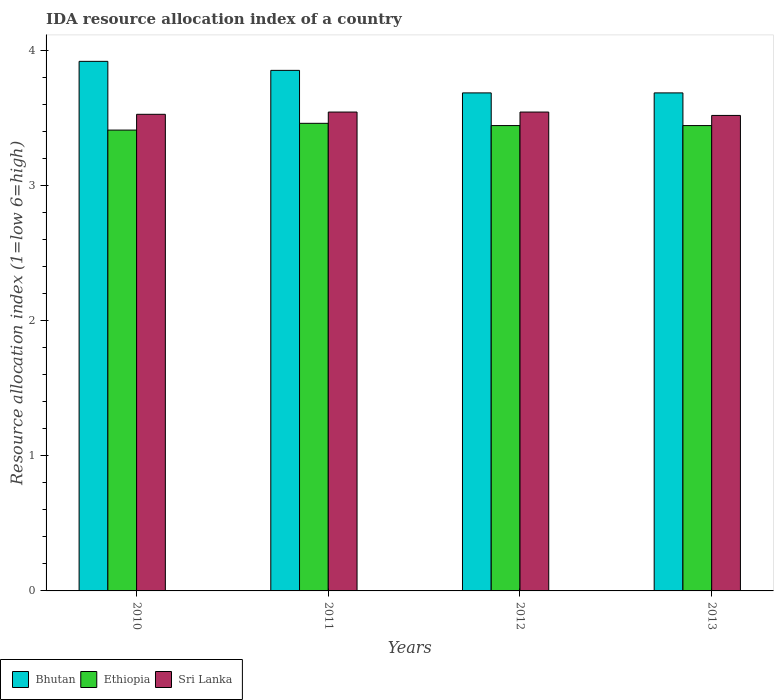How many different coloured bars are there?
Offer a terse response. 3. Are the number of bars on each tick of the X-axis equal?
Ensure brevity in your answer.  Yes. How many bars are there on the 2nd tick from the left?
Your response must be concise. 3. What is the label of the 4th group of bars from the left?
Your answer should be very brief. 2013. In how many cases, is the number of bars for a given year not equal to the number of legend labels?
Your answer should be compact. 0. What is the IDA resource allocation index in Ethiopia in 2011?
Your answer should be very brief. 3.46. Across all years, what is the maximum IDA resource allocation index in Bhutan?
Provide a short and direct response. 3.92. Across all years, what is the minimum IDA resource allocation index in Ethiopia?
Your answer should be compact. 3.41. In which year was the IDA resource allocation index in Sri Lanka maximum?
Keep it short and to the point. 2011. In which year was the IDA resource allocation index in Sri Lanka minimum?
Keep it short and to the point. 2013. What is the total IDA resource allocation index in Bhutan in the graph?
Give a very brief answer. 15.13. What is the difference between the IDA resource allocation index in Bhutan in 2010 and that in 2012?
Give a very brief answer. 0.23. What is the difference between the IDA resource allocation index in Ethiopia in 2010 and the IDA resource allocation index in Bhutan in 2013?
Your answer should be very brief. -0.27. What is the average IDA resource allocation index in Sri Lanka per year?
Offer a very short reply. 3.53. In the year 2011, what is the difference between the IDA resource allocation index in Ethiopia and IDA resource allocation index in Sri Lanka?
Provide a short and direct response. -0.08. In how many years, is the IDA resource allocation index in Ethiopia greater than 2.8?
Provide a succinct answer. 4. What is the ratio of the IDA resource allocation index in Bhutan in 2011 to that in 2012?
Offer a very short reply. 1.05. Is the IDA resource allocation index in Bhutan in 2011 less than that in 2012?
Provide a succinct answer. No. Is the difference between the IDA resource allocation index in Ethiopia in 2011 and 2012 greater than the difference between the IDA resource allocation index in Sri Lanka in 2011 and 2012?
Give a very brief answer. Yes. What is the difference between the highest and the second highest IDA resource allocation index in Ethiopia?
Offer a terse response. 0.02. What is the difference between the highest and the lowest IDA resource allocation index in Sri Lanka?
Your response must be concise. 0.02. What does the 2nd bar from the left in 2010 represents?
Offer a very short reply. Ethiopia. What does the 2nd bar from the right in 2013 represents?
Keep it short and to the point. Ethiopia. Is it the case that in every year, the sum of the IDA resource allocation index in Sri Lanka and IDA resource allocation index in Bhutan is greater than the IDA resource allocation index in Ethiopia?
Give a very brief answer. Yes. Are all the bars in the graph horizontal?
Offer a very short reply. No. Are the values on the major ticks of Y-axis written in scientific E-notation?
Make the answer very short. No. Does the graph contain any zero values?
Keep it short and to the point. No. Does the graph contain grids?
Make the answer very short. No. Where does the legend appear in the graph?
Ensure brevity in your answer.  Bottom left. How many legend labels are there?
Your answer should be very brief. 3. What is the title of the graph?
Your response must be concise. IDA resource allocation index of a country. Does "Arab World" appear as one of the legend labels in the graph?
Provide a short and direct response. No. What is the label or title of the X-axis?
Provide a short and direct response. Years. What is the label or title of the Y-axis?
Keep it short and to the point. Resource allocation index (1=low 6=high). What is the Resource allocation index (1=low 6=high) in Bhutan in 2010?
Offer a terse response. 3.92. What is the Resource allocation index (1=low 6=high) of Ethiopia in 2010?
Your answer should be very brief. 3.41. What is the Resource allocation index (1=low 6=high) of Sri Lanka in 2010?
Offer a terse response. 3.52. What is the Resource allocation index (1=low 6=high) in Bhutan in 2011?
Ensure brevity in your answer.  3.85. What is the Resource allocation index (1=low 6=high) of Ethiopia in 2011?
Your answer should be very brief. 3.46. What is the Resource allocation index (1=low 6=high) in Sri Lanka in 2011?
Offer a terse response. 3.54. What is the Resource allocation index (1=low 6=high) in Bhutan in 2012?
Make the answer very short. 3.68. What is the Resource allocation index (1=low 6=high) in Ethiopia in 2012?
Make the answer very short. 3.44. What is the Resource allocation index (1=low 6=high) of Sri Lanka in 2012?
Make the answer very short. 3.54. What is the Resource allocation index (1=low 6=high) in Bhutan in 2013?
Ensure brevity in your answer.  3.68. What is the Resource allocation index (1=low 6=high) of Ethiopia in 2013?
Ensure brevity in your answer.  3.44. What is the Resource allocation index (1=low 6=high) in Sri Lanka in 2013?
Your answer should be very brief. 3.52. Across all years, what is the maximum Resource allocation index (1=low 6=high) of Bhutan?
Give a very brief answer. 3.92. Across all years, what is the maximum Resource allocation index (1=low 6=high) in Ethiopia?
Provide a succinct answer. 3.46. Across all years, what is the maximum Resource allocation index (1=low 6=high) of Sri Lanka?
Offer a terse response. 3.54. Across all years, what is the minimum Resource allocation index (1=low 6=high) in Bhutan?
Ensure brevity in your answer.  3.68. Across all years, what is the minimum Resource allocation index (1=low 6=high) in Ethiopia?
Your response must be concise. 3.41. Across all years, what is the minimum Resource allocation index (1=low 6=high) in Sri Lanka?
Ensure brevity in your answer.  3.52. What is the total Resource allocation index (1=low 6=high) in Bhutan in the graph?
Provide a short and direct response. 15.13. What is the total Resource allocation index (1=low 6=high) of Ethiopia in the graph?
Offer a terse response. 13.75. What is the total Resource allocation index (1=low 6=high) in Sri Lanka in the graph?
Your response must be concise. 14.12. What is the difference between the Resource allocation index (1=low 6=high) in Bhutan in 2010 and that in 2011?
Offer a very short reply. 0.07. What is the difference between the Resource allocation index (1=low 6=high) of Ethiopia in 2010 and that in 2011?
Provide a short and direct response. -0.05. What is the difference between the Resource allocation index (1=low 6=high) of Sri Lanka in 2010 and that in 2011?
Provide a succinct answer. -0.02. What is the difference between the Resource allocation index (1=low 6=high) of Bhutan in 2010 and that in 2012?
Your answer should be very brief. 0.23. What is the difference between the Resource allocation index (1=low 6=high) in Ethiopia in 2010 and that in 2012?
Keep it short and to the point. -0.03. What is the difference between the Resource allocation index (1=low 6=high) in Sri Lanka in 2010 and that in 2012?
Provide a short and direct response. -0.02. What is the difference between the Resource allocation index (1=low 6=high) of Bhutan in 2010 and that in 2013?
Provide a succinct answer. 0.23. What is the difference between the Resource allocation index (1=low 6=high) in Ethiopia in 2010 and that in 2013?
Your response must be concise. -0.03. What is the difference between the Resource allocation index (1=low 6=high) in Sri Lanka in 2010 and that in 2013?
Ensure brevity in your answer.  0.01. What is the difference between the Resource allocation index (1=low 6=high) of Bhutan in 2011 and that in 2012?
Give a very brief answer. 0.17. What is the difference between the Resource allocation index (1=low 6=high) of Ethiopia in 2011 and that in 2012?
Your answer should be very brief. 0.02. What is the difference between the Resource allocation index (1=low 6=high) in Sri Lanka in 2011 and that in 2012?
Give a very brief answer. 0. What is the difference between the Resource allocation index (1=low 6=high) in Ethiopia in 2011 and that in 2013?
Your answer should be compact. 0.02. What is the difference between the Resource allocation index (1=low 6=high) in Sri Lanka in 2011 and that in 2013?
Offer a very short reply. 0.03. What is the difference between the Resource allocation index (1=low 6=high) in Ethiopia in 2012 and that in 2013?
Provide a short and direct response. 0. What is the difference between the Resource allocation index (1=low 6=high) of Sri Lanka in 2012 and that in 2013?
Offer a very short reply. 0.03. What is the difference between the Resource allocation index (1=low 6=high) in Bhutan in 2010 and the Resource allocation index (1=low 6=high) in Ethiopia in 2011?
Provide a succinct answer. 0.46. What is the difference between the Resource allocation index (1=low 6=high) of Bhutan in 2010 and the Resource allocation index (1=low 6=high) of Sri Lanka in 2011?
Your answer should be very brief. 0.38. What is the difference between the Resource allocation index (1=low 6=high) in Ethiopia in 2010 and the Resource allocation index (1=low 6=high) in Sri Lanka in 2011?
Keep it short and to the point. -0.13. What is the difference between the Resource allocation index (1=low 6=high) in Bhutan in 2010 and the Resource allocation index (1=low 6=high) in Ethiopia in 2012?
Ensure brevity in your answer.  0.47. What is the difference between the Resource allocation index (1=low 6=high) of Bhutan in 2010 and the Resource allocation index (1=low 6=high) of Sri Lanka in 2012?
Ensure brevity in your answer.  0.38. What is the difference between the Resource allocation index (1=low 6=high) of Ethiopia in 2010 and the Resource allocation index (1=low 6=high) of Sri Lanka in 2012?
Your answer should be very brief. -0.13. What is the difference between the Resource allocation index (1=low 6=high) in Bhutan in 2010 and the Resource allocation index (1=low 6=high) in Ethiopia in 2013?
Offer a very short reply. 0.47. What is the difference between the Resource allocation index (1=low 6=high) in Ethiopia in 2010 and the Resource allocation index (1=low 6=high) in Sri Lanka in 2013?
Give a very brief answer. -0.11. What is the difference between the Resource allocation index (1=low 6=high) in Bhutan in 2011 and the Resource allocation index (1=low 6=high) in Ethiopia in 2012?
Give a very brief answer. 0.41. What is the difference between the Resource allocation index (1=low 6=high) in Bhutan in 2011 and the Resource allocation index (1=low 6=high) in Sri Lanka in 2012?
Make the answer very short. 0.31. What is the difference between the Resource allocation index (1=low 6=high) in Ethiopia in 2011 and the Resource allocation index (1=low 6=high) in Sri Lanka in 2012?
Offer a terse response. -0.08. What is the difference between the Resource allocation index (1=low 6=high) in Bhutan in 2011 and the Resource allocation index (1=low 6=high) in Ethiopia in 2013?
Offer a terse response. 0.41. What is the difference between the Resource allocation index (1=low 6=high) of Bhutan in 2011 and the Resource allocation index (1=low 6=high) of Sri Lanka in 2013?
Your answer should be very brief. 0.33. What is the difference between the Resource allocation index (1=low 6=high) of Ethiopia in 2011 and the Resource allocation index (1=low 6=high) of Sri Lanka in 2013?
Keep it short and to the point. -0.06. What is the difference between the Resource allocation index (1=low 6=high) in Bhutan in 2012 and the Resource allocation index (1=low 6=high) in Ethiopia in 2013?
Keep it short and to the point. 0.24. What is the difference between the Resource allocation index (1=low 6=high) in Ethiopia in 2012 and the Resource allocation index (1=low 6=high) in Sri Lanka in 2013?
Your response must be concise. -0.07. What is the average Resource allocation index (1=low 6=high) of Bhutan per year?
Your answer should be compact. 3.78. What is the average Resource allocation index (1=low 6=high) of Ethiopia per year?
Offer a terse response. 3.44. What is the average Resource allocation index (1=low 6=high) in Sri Lanka per year?
Your answer should be compact. 3.53. In the year 2010, what is the difference between the Resource allocation index (1=low 6=high) in Bhutan and Resource allocation index (1=low 6=high) in Ethiopia?
Offer a terse response. 0.51. In the year 2010, what is the difference between the Resource allocation index (1=low 6=high) of Bhutan and Resource allocation index (1=low 6=high) of Sri Lanka?
Make the answer very short. 0.39. In the year 2010, what is the difference between the Resource allocation index (1=low 6=high) of Ethiopia and Resource allocation index (1=low 6=high) of Sri Lanka?
Offer a terse response. -0.12. In the year 2011, what is the difference between the Resource allocation index (1=low 6=high) of Bhutan and Resource allocation index (1=low 6=high) of Ethiopia?
Ensure brevity in your answer.  0.39. In the year 2011, what is the difference between the Resource allocation index (1=low 6=high) in Bhutan and Resource allocation index (1=low 6=high) in Sri Lanka?
Your answer should be very brief. 0.31. In the year 2011, what is the difference between the Resource allocation index (1=low 6=high) of Ethiopia and Resource allocation index (1=low 6=high) of Sri Lanka?
Your answer should be very brief. -0.08. In the year 2012, what is the difference between the Resource allocation index (1=low 6=high) in Bhutan and Resource allocation index (1=low 6=high) in Ethiopia?
Offer a terse response. 0.24. In the year 2012, what is the difference between the Resource allocation index (1=low 6=high) in Bhutan and Resource allocation index (1=low 6=high) in Sri Lanka?
Provide a succinct answer. 0.14. In the year 2013, what is the difference between the Resource allocation index (1=low 6=high) of Bhutan and Resource allocation index (1=low 6=high) of Ethiopia?
Your answer should be very brief. 0.24. In the year 2013, what is the difference between the Resource allocation index (1=low 6=high) in Ethiopia and Resource allocation index (1=low 6=high) in Sri Lanka?
Make the answer very short. -0.07. What is the ratio of the Resource allocation index (1=low 6=high) of Bhutan in 2010 to that in 2011?
Your response must be concise. 1.02. What is the ratio of the Resource allocation index (1=low 6=high) of Ethiopia in 2010 to that in 2011?
Ensure brevity in your answer.  0.99. What is the ratio of the Resource allocation index (1=low 6=high) of Sri Lanka in 2010 to that in 2011?
Provide a short and direct response. 1. What is the ratio of the Resource allocation index (1=low 6=high) in Bhutan in 2010 to that in 2012?
Offer a terse response. 1.06. What is the ratio of the Resource allocation index (1=low 6=high) of Ethiopia in 2010 to that in 2012?
Your response must be concise. 0.99. What is the ratio of the Resource allocation index (1=low 6=high) in Sri Lanka in 2010 to that in 2012?
Your answer should be very brief. 1. What is the ratio of the Resource allocation index (1=low 6=high) of Bhutan in 2010 to that in 2013?
Your response must be concise. 1.06. What is the ratio of the Resource allocation index (1=low 6=high) of Ethiopia in 2010 to that in 2013?
Keep it short and to the point. 0.99. What is the ratio of the Resource allocation index (1=low 6=high) of Bhutan in 2011 to that in 2012?
Your response must be concise. 1.05. What is the ratio of the Resource allocation index (1=low 6=high) of Ethiopia in 2011 to that in 2012?
Your answer should be very brief. 1. What is the ratio of the Resource allocation index (1=low 6=high) of Sri Lanka in 2011 to that in 2012?
Your answer should be compact. 1. What is the ratio of the Resource allocation index (1=low 6=high) in Bhutan in 2011 to that in 2013?
Make the answer very short. 1.05. What is the ratio of the Resource allocation index (1=low 6=high) of Ethiopia in 2011 to that in 2013?
Ensure brevity in your answer.  1. What is the ratio of the Resource allocation index (1=low 6=high) in Sri Lanka in 2011 to that in 2013?
Give a very brief answer. 1.01. What is the ratio of the Resource allocation index (1=low 6=high) of Sri Lanka in 2012 to that in 2013?
Offer a very short reply. 1.01. What is the difference between the highest and the second highest Resource allocation index (1=low 6=high) in Bhutan?
Ensure brevity in your answer.  0.07. What is the difference between the highest and the second highest Resource allocation index (1=low 6=high) of Ethiopia?
Make the answer very short. 0.02. What is the difference between the highest and the lowest Resource allocation index (1=low 6=high) in Bhutan?
Your response must be concise. 0.23. What is the difference between the highest and the lowest Resource allocation index (1=low 6=high) of Sri Lanka?
Provide a short and direct response. 0.03. 